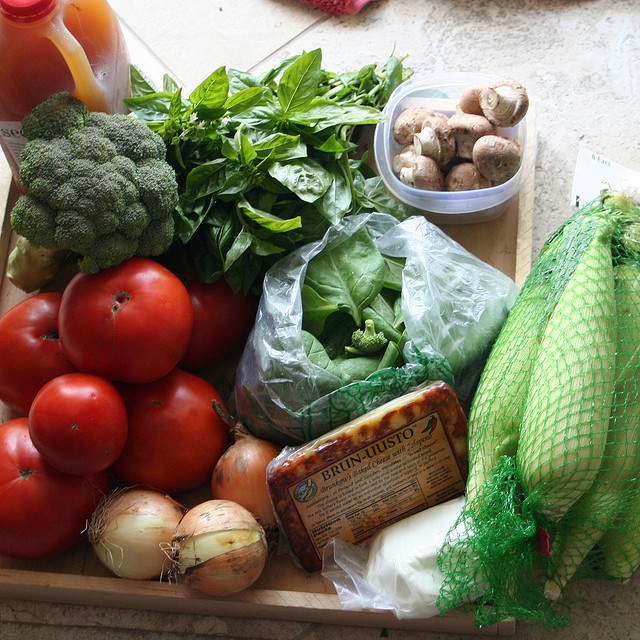Describe the objects in this image and their specific colors. I can see broccoli in brown, black, gray, darkgray, and darkgreen tones, bowl in brown, white, darkgray, maroon, and gray tones, bottle in pink, maroon, brown, and darkgray tones, and broccoli in brown, black, darkgreen, lightgreen, and olive tones in this image. 